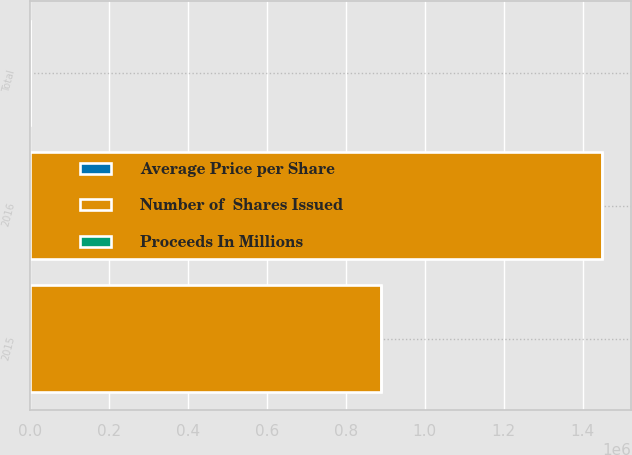<chart> <loc_0><loc_0><loc_500><loc_500><stacked_bar_chart><ecel><fcel>2015<fcel>2016<fcel>Total<nl><fcel>Number of  Shares Issued<fcel>888610<fcel>1.44917e+06<fcel>50.7<nl><fcel>Average Price per Share<fcel>33.76<fcel>41.4<fcel>38.5<nl><fcel>Proceeds In Millions<fcel>30<fcel>60<fcel>90<nl></chart> 